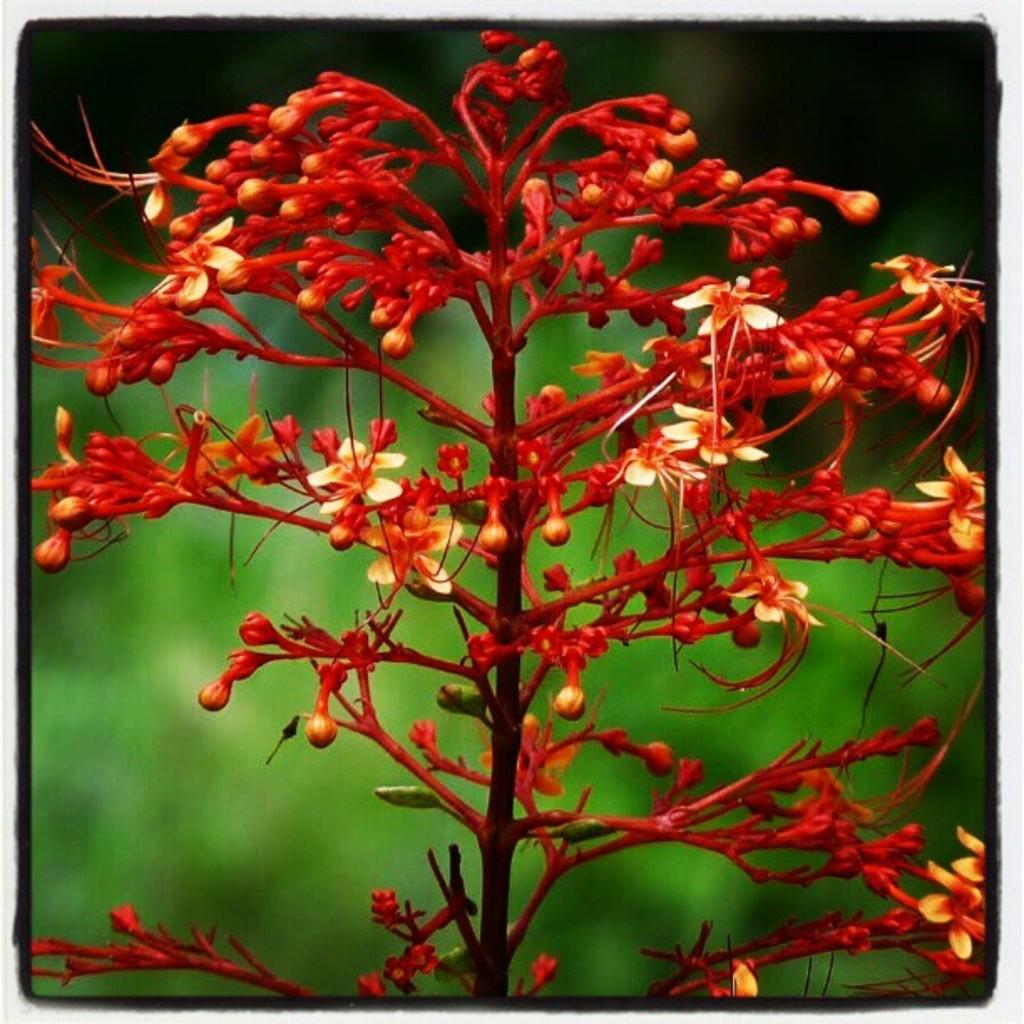What type of plants are in the image? There are flowers in the image. What color are the flowers? The flowers are red in color. What can be seen in the background of the image? The background of the image is green. What type of attack is being carried out by the flowers in the image? There is no attack being carried out by the flowers in the image; they are simply plants. 